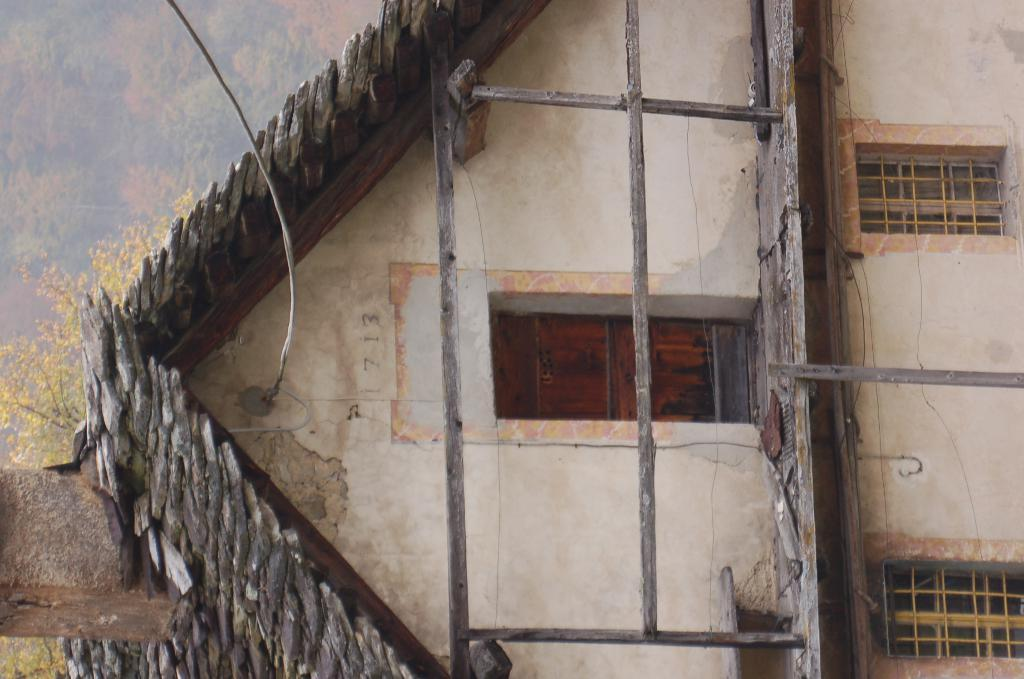What is the main subject of the image? The main subject of the image is a building. How is the building depicted in the image? The building appears to be in a painting. What architectural feature can be seen on the building? The building has stairs. What can be seen through the windows of the building? The building has windows, but the image does not show what can be seen through them. What type of crib is visible in the image? There is no crib present in the image; it features a building in a painting. What type of food is the cook preparing in the image? There is no cook or food preparation visible in the image; it only shows a building. 